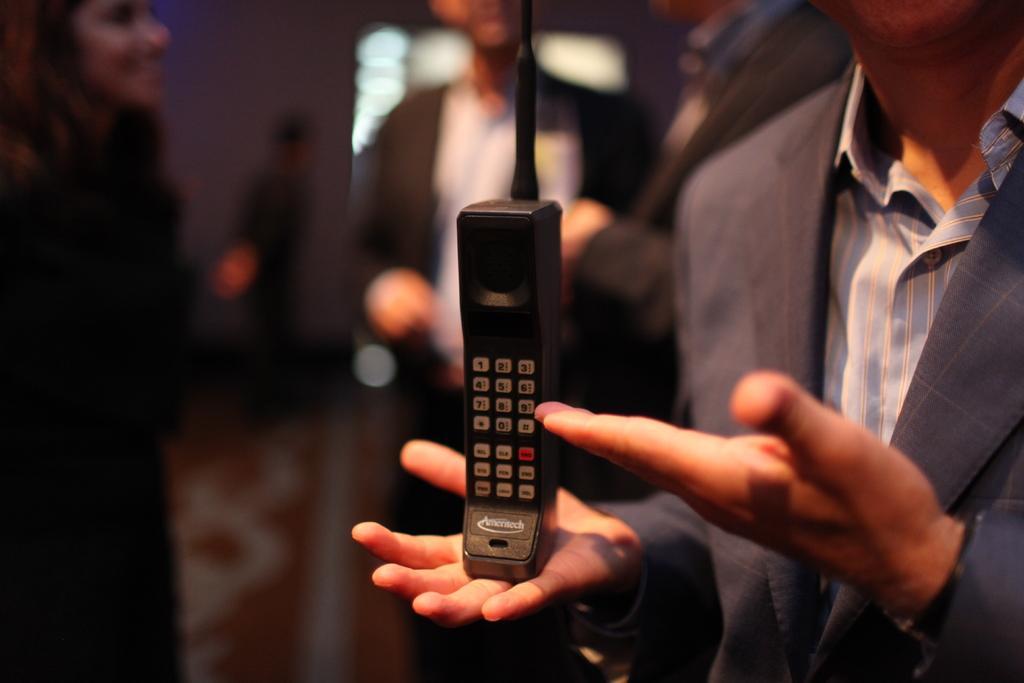In one or two sentences, can you explain what this image depicts? In the given image we can see there are many people around. This is a telephone. 